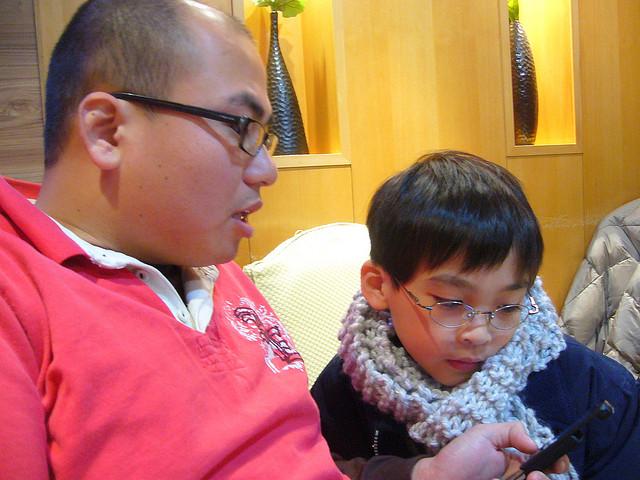What color is the man's shirt?
Short answer required. Red. How many people have glasses?
Quick response, please. 2. What are the people looking at?
Give a very brief answer. Phone. 